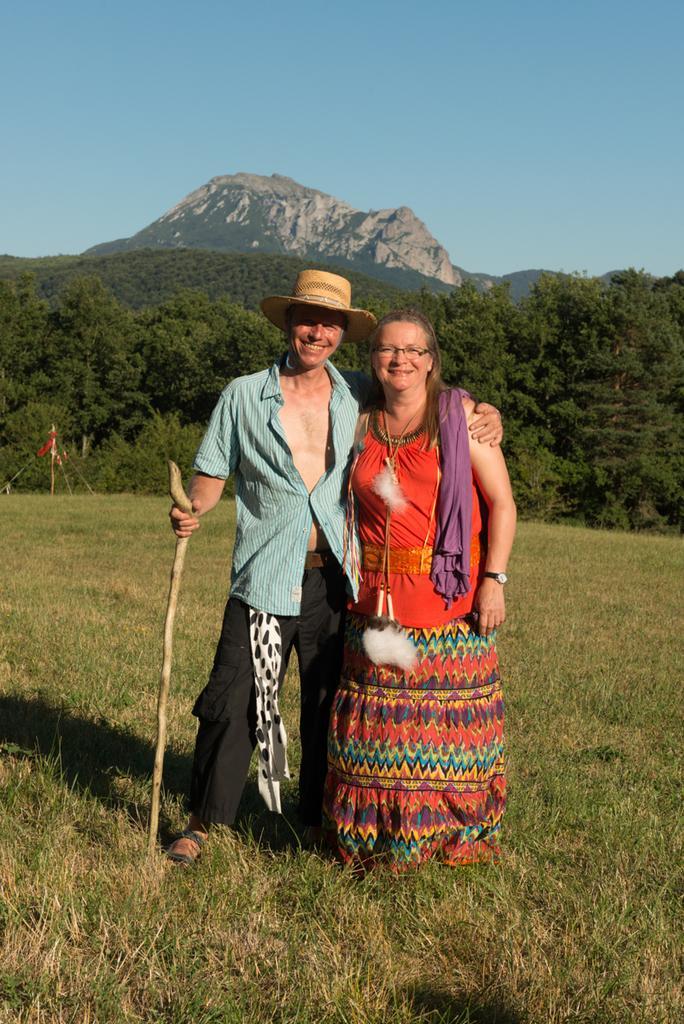Could you give a brief overview of what you see in this image? In this picture I can see a man, woman standing on the grass and holding stick, behind there are some trees and hills. 